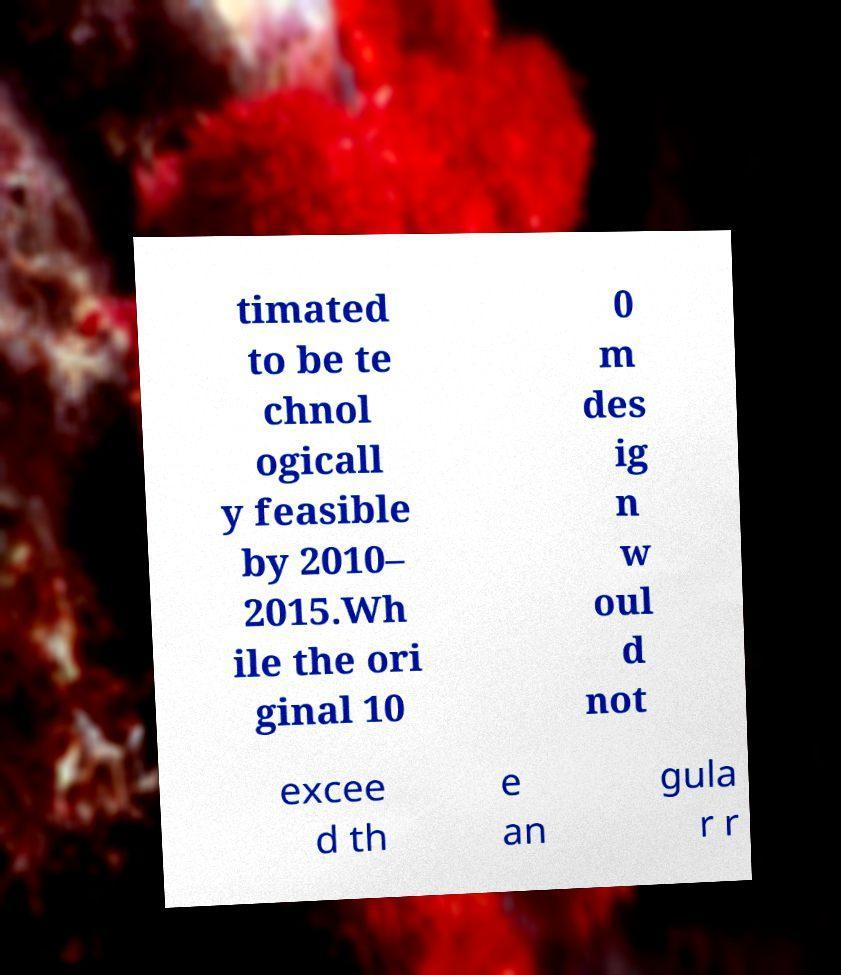Please read and relay the text visible in this image. What does it say? timated to be te chnol ogicall y feasible by 2010– 2015.Wh ile the ori ginal 10 0 m des ig n w oul d not excee d th e an gula r r 